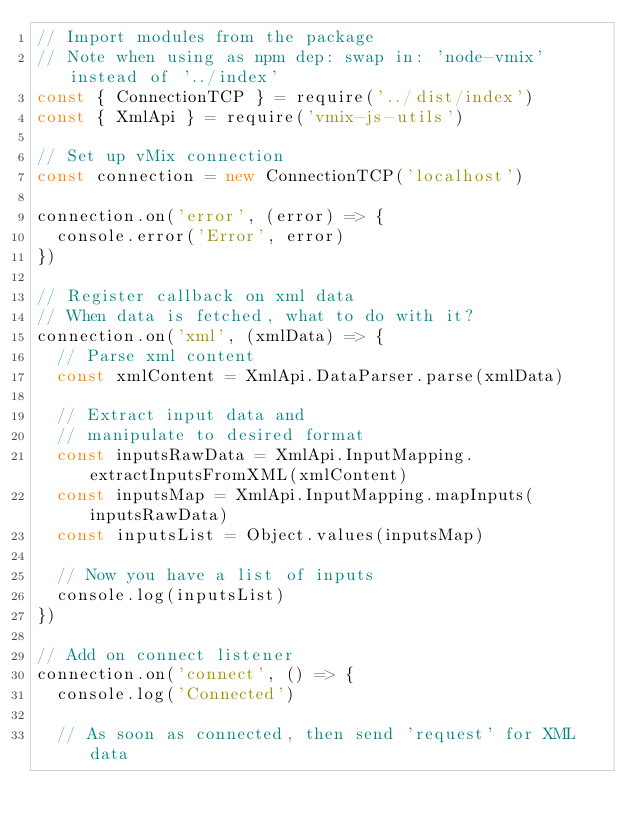Convert code to text. <code><loc_0><loc_0><loc_500><loc_500><_JavaScript_>// Import modules from the package
// Note when using as npm dep: swap in: 'node-vmix' instead of '../index'
const { ConnectionTCP } = require('../dist/index')
const { XmlApi } = require('vmix-js-utils')

// Set up vMix connection
const connection = new ConnectionTCP('localhost')

connection.on('error', (error) => {
  console.error('Error', error)
})

// Register callback on xml data
// When data is fetched, what to do with it?
connection.on('xml', (xmlData) => {
  // Parse xml content
  const xmlContent = XmlApi.DataParser.parse(xmlData)

  // Extract input data and
  // manipulate to desired format
  const inputsRawData = XmlApi.InputMapping.extractInputsFromXML(xmlContent)
  const inputsMap = XmlApi.InputMapping.mapInputs(inputsRawData)
  const inputsList = Object.values(inputsMap)

  // Now you have a list of inputs
  console.log(inputsList)
})

// Add on connect listener
connection.on('connect', () => {
  console.log('Connected')
  
  // As soon as connected, then send 'request' for XML data</code> 